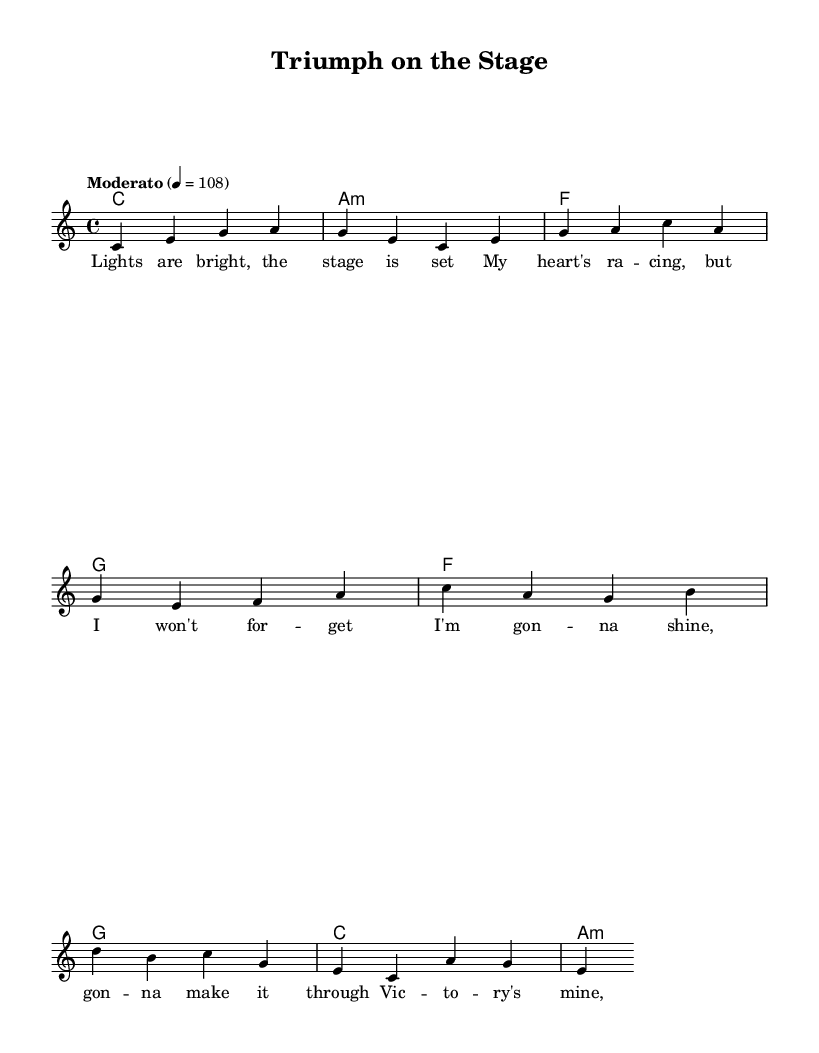What is the key signature of this music? The key signature is C major, which has no sharps or flats.
Answer: C major What is the time signature of this music? The time signature is found at the beginning of the staff and indicates the music is in 4/4 time, meaning there are four beats in each measure.
Answer: 4/4 What is the tempo marking for this piece? The tempo marking indicates that the piece should be performed at a moderate speed of 108 beats per minute, as specified at the beginning of the score.
Answer: Moderato 4 = 108 How many measures are there in the verse? By counting the distinct sections labeled as verse in the melody, we find there are four measures in the verse of the score.
Answer: 4 What type of chord is the first one in the verse? The first chord in the verse is labeled as C major, indicated by the chord symbols placed below the melody in the score.
Answer: C Which section contains the lyrics "I'm gonna shine, gonna make it through"? These lyrics are part of the chorus section, which is distinguished from the verse and is positioned after it in the sheet music.
Answer: Chorus How many different chords are used in the chorus? By analyzing the chords listed under the melody in the chorus, we can see that there are four unique chords: F, G, C, and A minor.
Answer: 4 